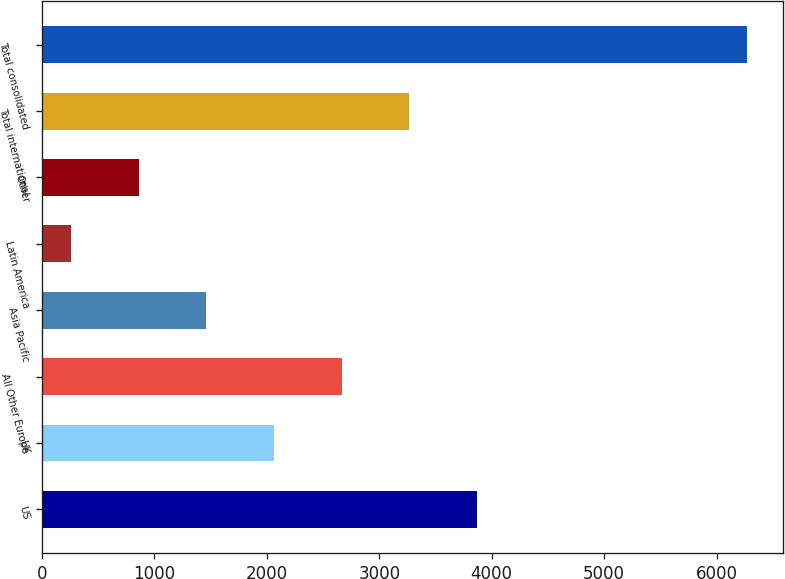<chart> <loc_0><loc_0><loc_500><loc_500><bar_chart><fcel>US<fcel>UK<fcel>All Other Europe<fcel>Asia Pacific<fcel>Latin America<fcel>Other<fcel>Total international<fcel>Total consolidated<nl><fcel>3868.46<fcel>2064.08<fcel>2665.54<fcel>1462.62<fcel>259.7<fcel>861.16<fcel>3267<fcel>6274.3<nl></chart> 